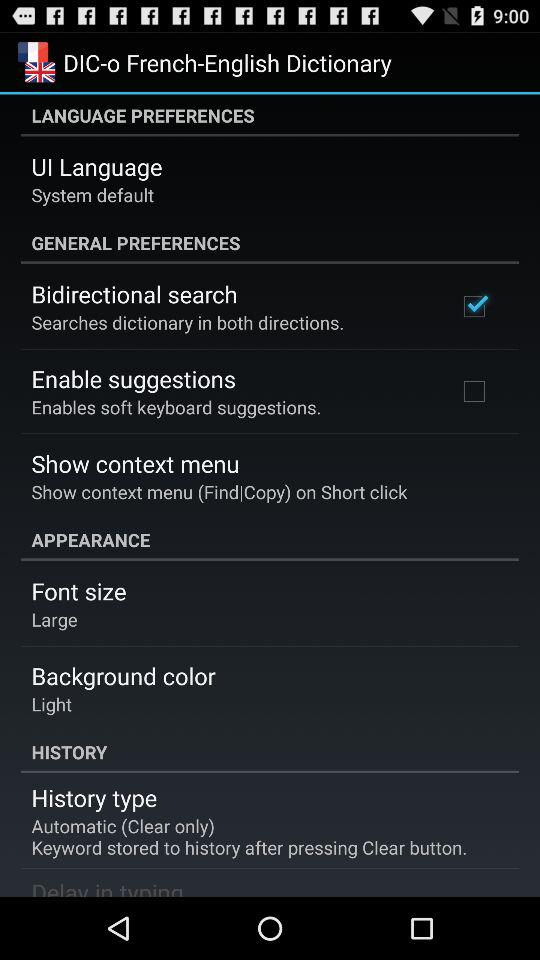What is the font size? The font size is large. 